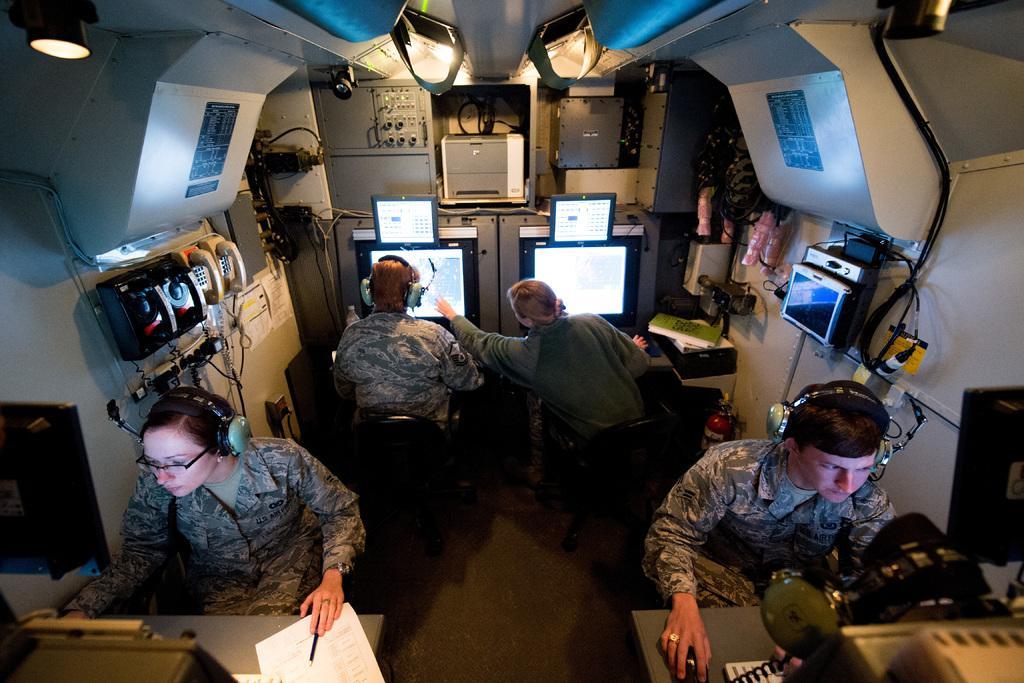How would you summarize this image in a sentence or two? In this image there are four people and three of them are wearing headsets, in the foreground there are two people who are sitting. In front of them there are tables, on the tables there are computers, keyboard, mouses, papers, pen, and in the background there are two people sitting and in front of them there are computers and some objects, papers, books. And on the right side and left side there are some telephones, wires and some other machines. And in the background there are some boxes machines and some other objects and also we could see some lights. 